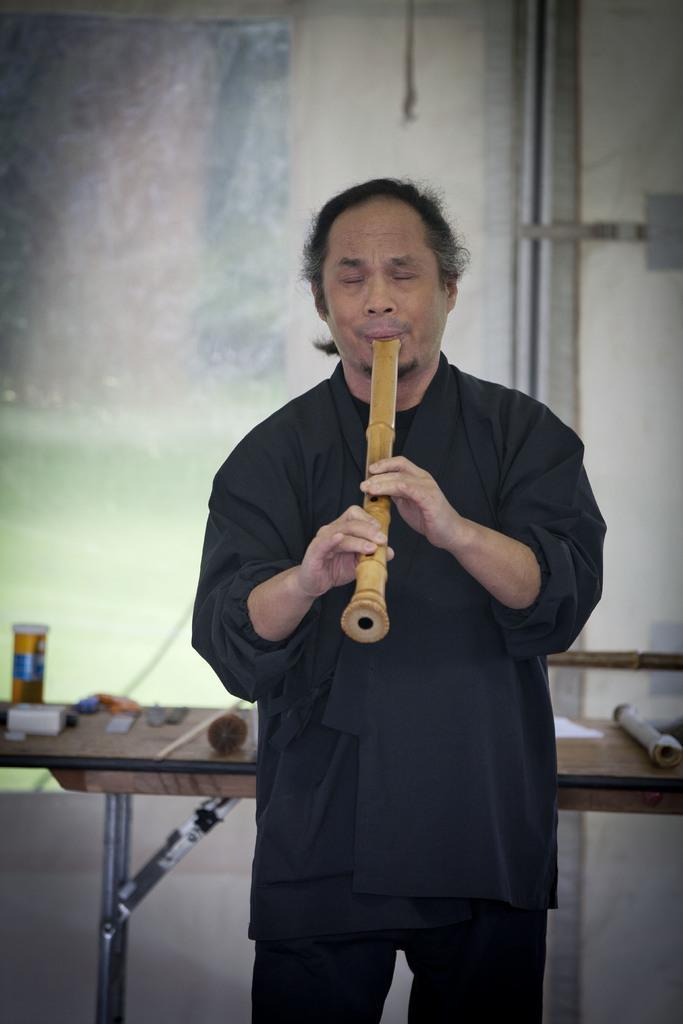How would you summarize this image in a sentence or two? Here we can see a man playing a musical instrument and behind him there is a table and something pressing on it 